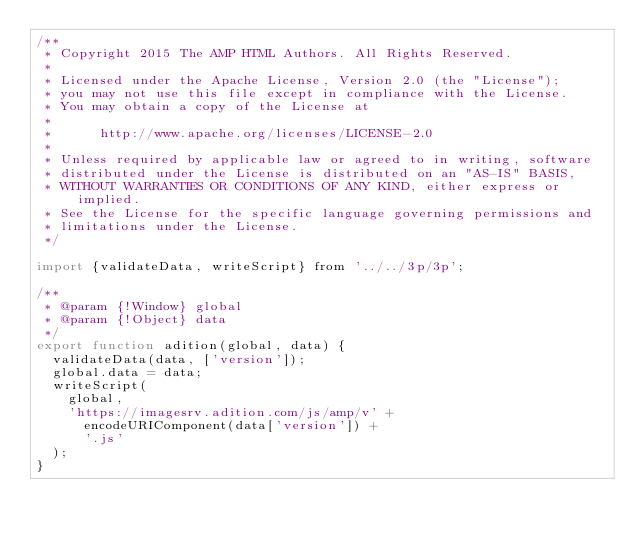Convert code to text. <code><loc_0><loc_0><loc_500><loc_500><_JavaScript_>/**
 * Copyright 2015 The AMP HTML Authors. All Rights Reserved.
 *
 * Licensed under the Apache License, Version 2.0 (the "License");
 * you may not use this file except in compliance with the License.
 * You may obtain a copy of the License at
 *
 *      http://www.apache.org/licenses/LICENSE-2.0
 *
 * Unless required by applicable law or agreed to in writing, software
 * distributed under the License is distributed on an "AS-IS" BASIS,
 * WITHOUT WARRANTIES OR CONDITIONS OF ANY KIND, either express or implied.
 * See the License for the specific language governing permissions and
 * limitations under the License.
 */

import {validateData, writeScript} from '../../3p/3p';

/**
 * @param {!Window} global
 * @param {!Object} data
 */
export function adition(global, data) {
  validateData(data, ['version']);
  global.data = data;
  writeScript(
    global,
    'https://imagesrv.adition.com/js/amp/v' +
      encodeURIComponent(data['version']) +
      '.js'
  );
}
</code> 